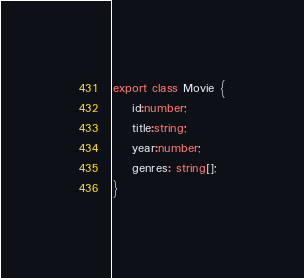<code> <loc_0><loc_0><loc_500><loc_500><_TypeScript_>export class Movie {
    id:number;
    title:string;
    year:number;
    genres: string[];
}</code> 